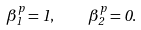<formula> <loc_0><loc_0><loc_500><loc_500>\beta _ { 1 } ^ { p } = 1 , \quad \beta _ { 2 } ^ { p } = 0 .</formula> 